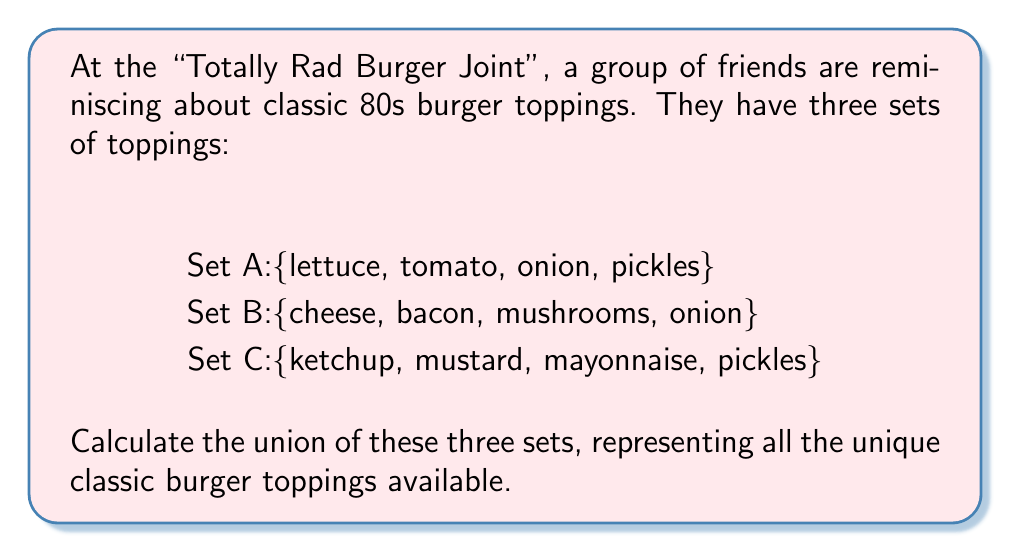Could you help me with this problem? To solve this problem, we need to find the union of sets A, B, and C. The union of sets includes all unique elements from all sets, without duplicates.

Let's denote the union as $A \cup B \cup C$.

Step 1: List all elements from set A:
$A = \{lettuce, tomato, onion, pickles\}$

Step 2: Add unique elements from set B:
$A \cup B = \{lettuce, tomato, onion, pickles, cheese, bacon, mushrooms\}$
Note that "onion" is already included, so we don't add it again.

Step 3: Add unique elements from set C:
$A \cup B \cup C = \{lettuce, tomato, onion, pickles, cheese, bacon, mushrooms, ketchup, mustard, mayonnaise\}$
Note that "pickles" is already included, so we don't add it again.

Step 4: Count the number of elements in the union:
$|A \cup B \cup C| = 10$

Therefore, the union of the three sets contains 10 unique classic burger toppings.
Answer: $A \cup B \cup C = \{lettuce, tomato, onion, pickles, cheese, bacon, mushrooms, ketchup, mustard, mayonnaise\}$ 